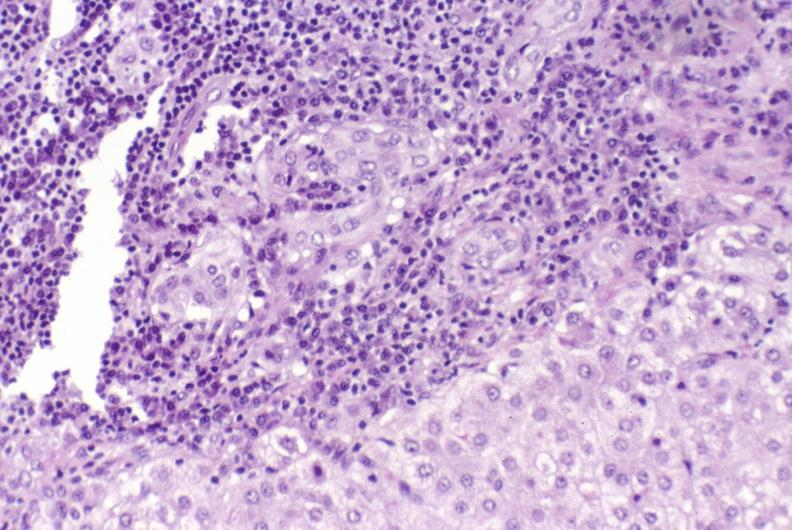does exposure show primary biliary cirrhosis?
Answer the question using a single word or phrase. No 